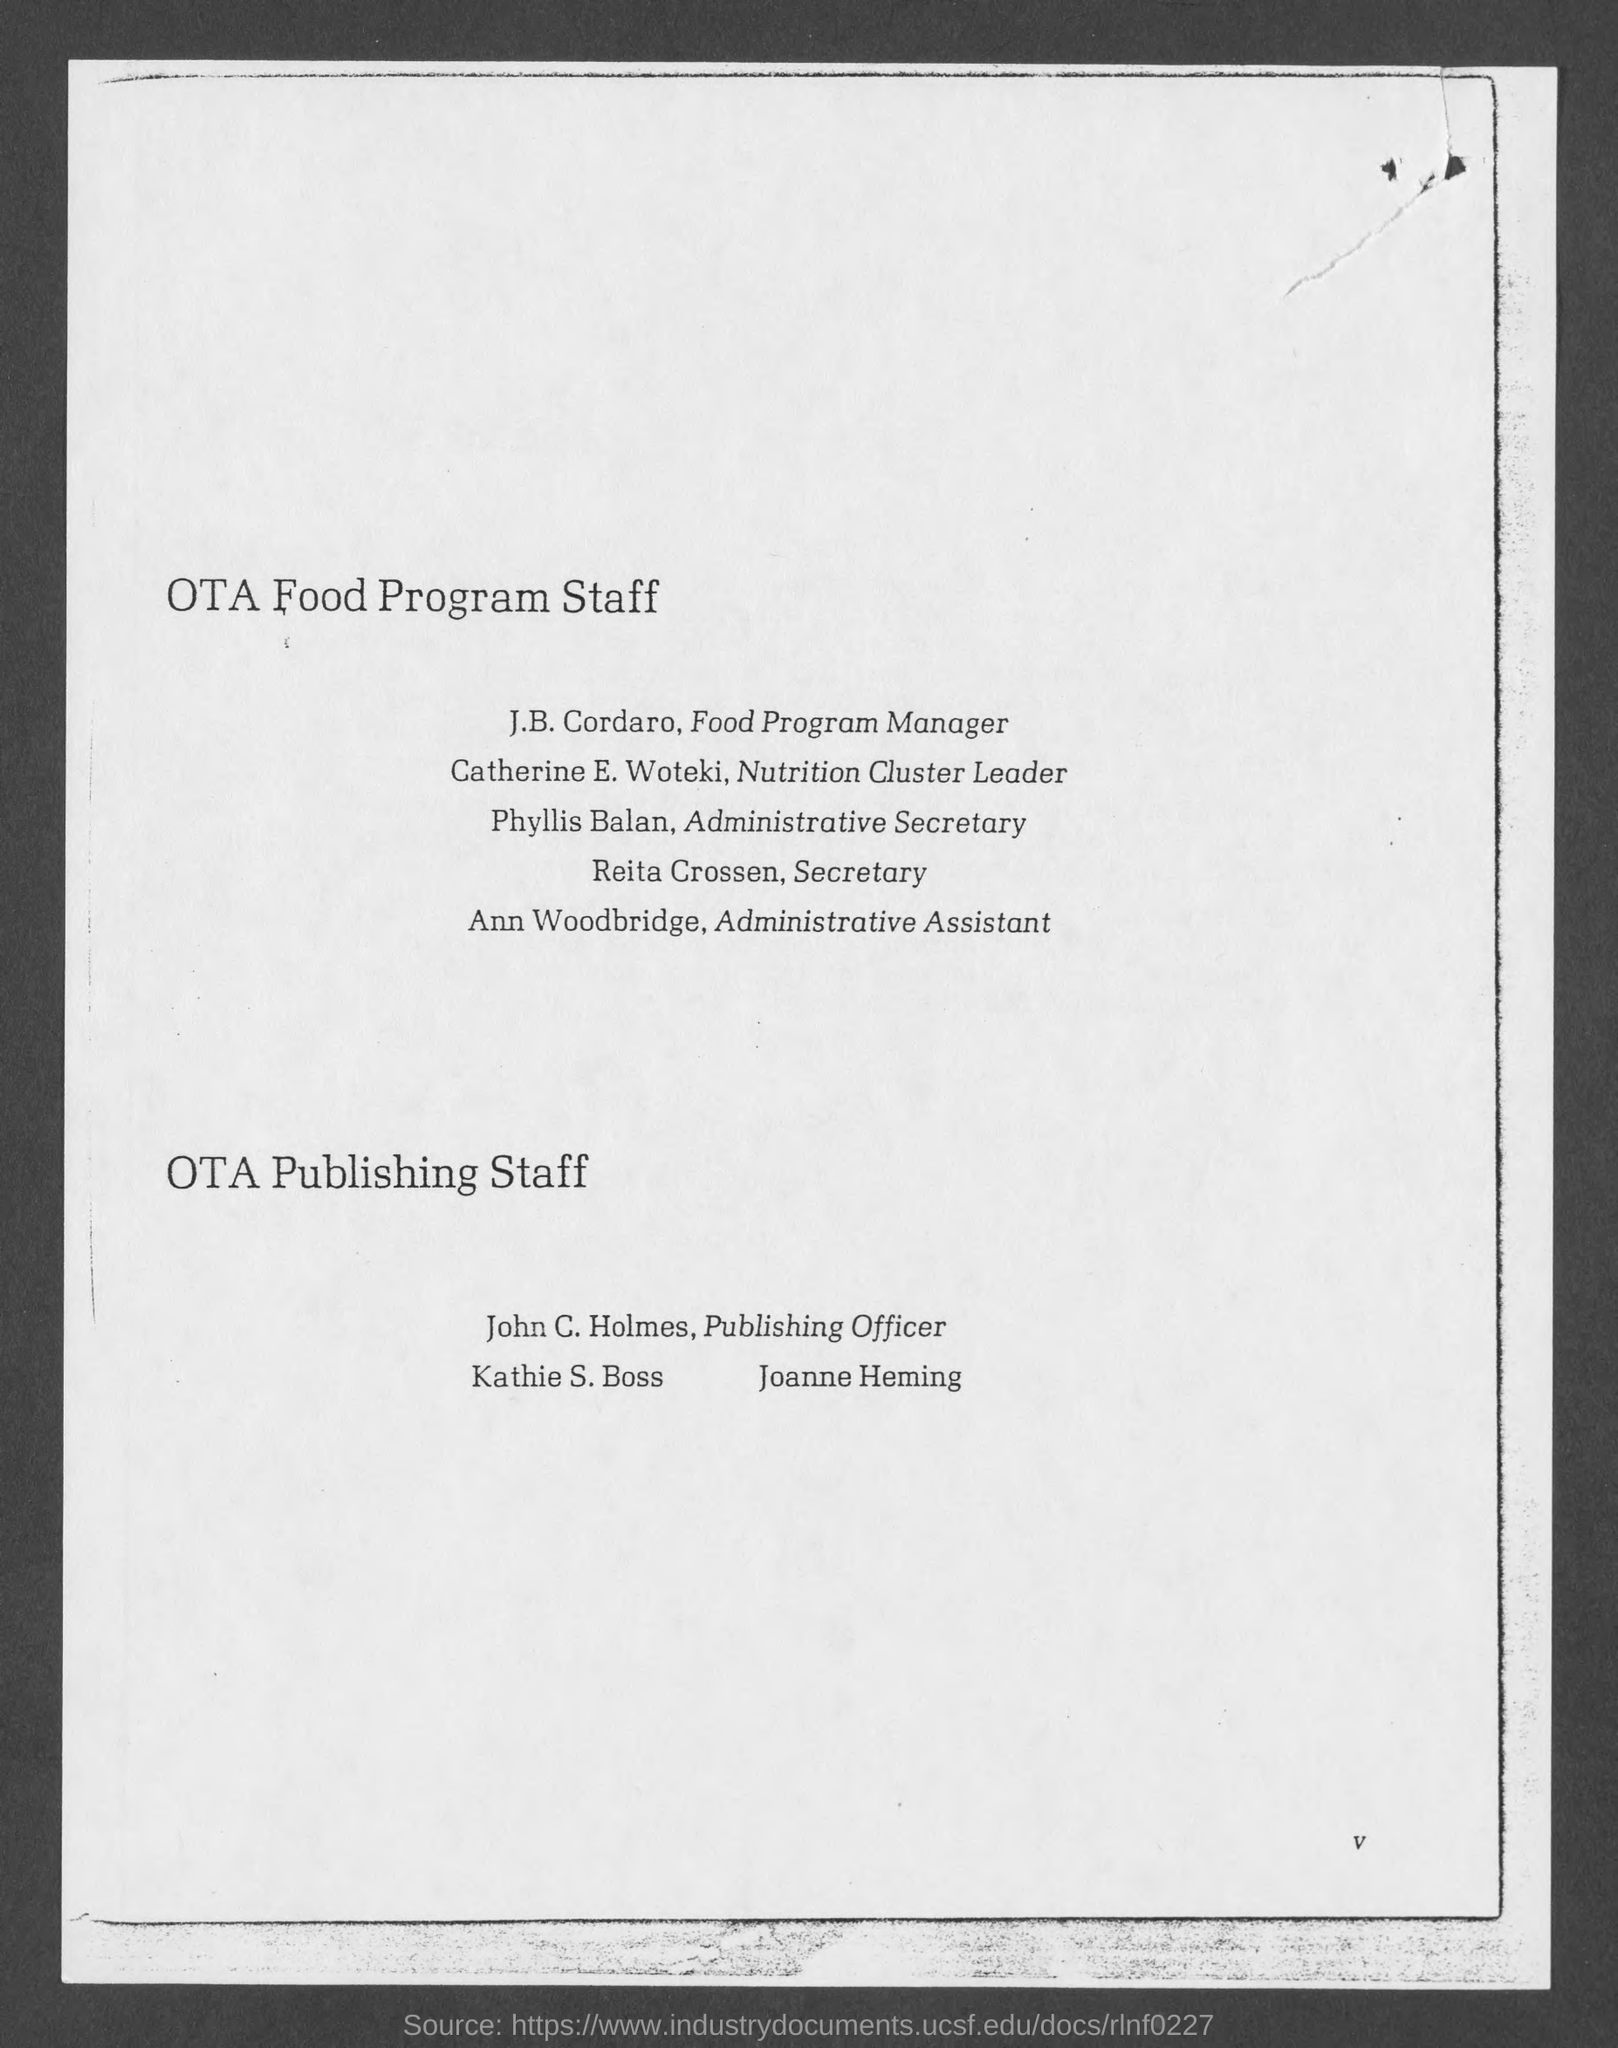Draw attention to some important aspects in this diagram. Phyllis Balan is the Administrative Secretary. The Secretary is Reita Crossen. 